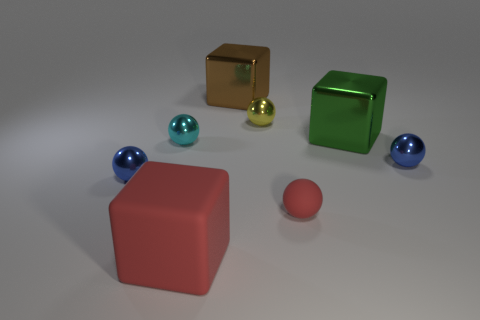What number of other blue objects are the same shape as the tiny matte object?
Offer a terse response. 2. What material is the green object?
Make the answer very short. Metal. Is the shape of the brown object the same as the big rubber thing?
Ensure brevity in your answer.  Yes. Is there a tiny red thing made of the same material as the red block?
Give a very brief answer. Yes. The metal thing that is both right of the cyan ball and in front of the small cyan shiny object is what color?
Make the answer very short. Blue. There is a red thing that is in front of the small red rubber ball; what material is it?
Give a very brief answer. Rubber. Is there a brown object of the same shape as the large green thing?
Give a very brief answer. Yes. What number of other objects are there of the same shape as the big red thing?
Your answer should be compact. 2. Is the shape of the big red thing the same as the blue metallic thing to the right of the green metal block?
Offer a very short reply. No. Are there any other things that are the same material as the cyan sphere?
Your response must be concise. Yes. 